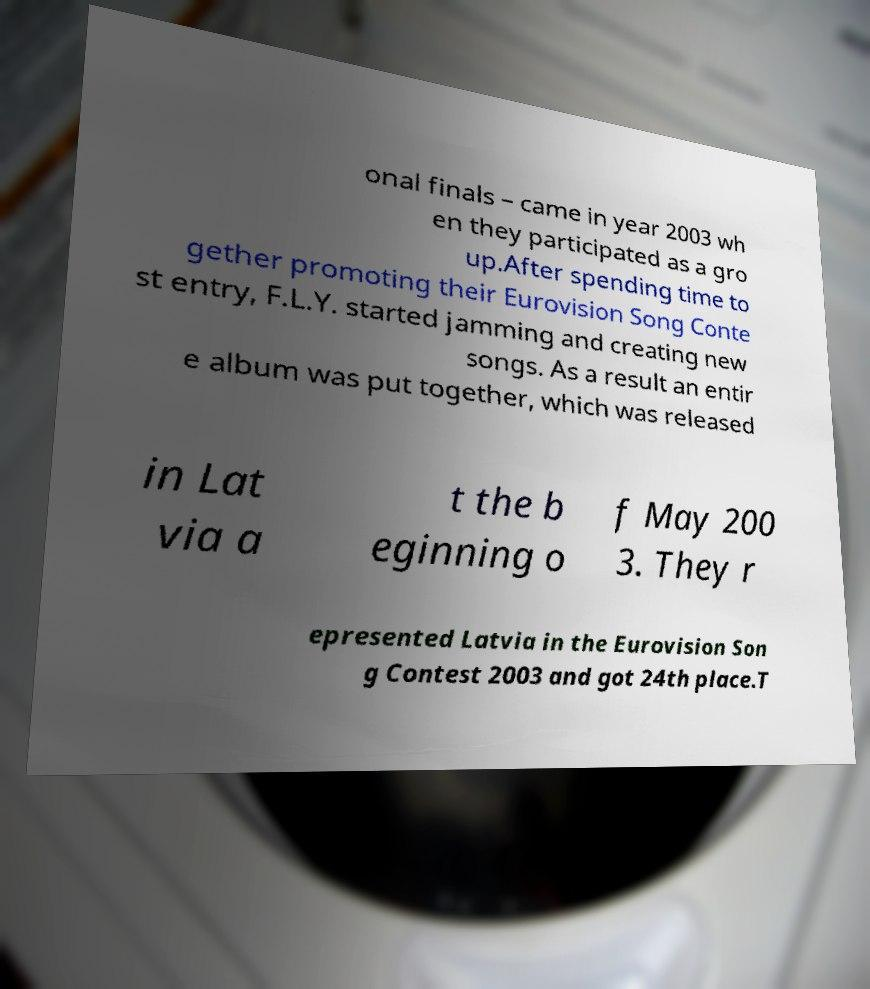For documentation purposes, I need the text within this image transcribed. Could you provide that? onal finals – came in year 2003 wh en they participated as a gro up.After spending time to gether promoting their Eurovision Song Conte st entry, F.L.Y. started jamming and creating new songs. As a result an entir e album was put together, which was released in Lat via a t the b eginning o f May 200 3. They r epresented Latvia in the Eurovision Son g Contest 2003 and got 24th place.T 